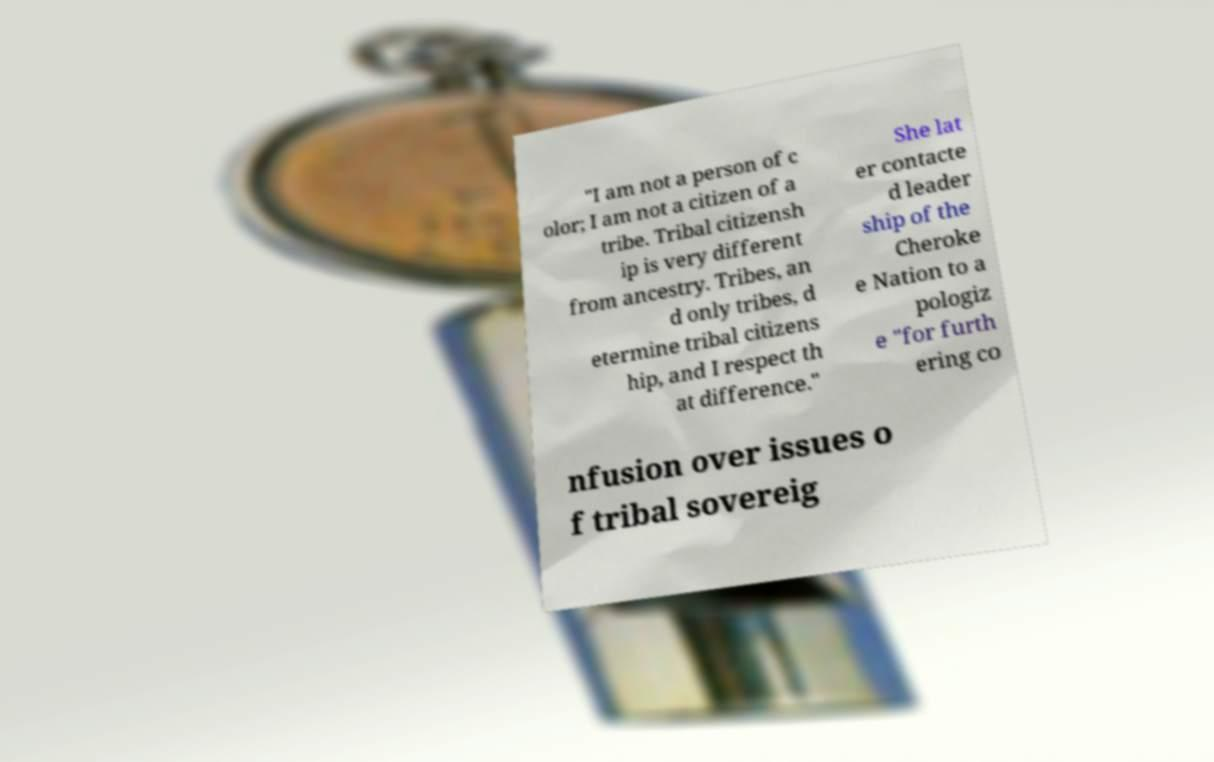Please read and relay the text visible in this image. What does it say? "I am not a person of c olor; I am not a citizen of a tribe. Tribal citizensh ip is very different from ancestry. Tribes, an d only tribes, d etermine tribal citizens hip, and I respect th at difference." She lat er contacte d leader ship of the Cheroke e Nation to a pologiz e "for furth ering co nfusion over issues o f tribal sovereig 